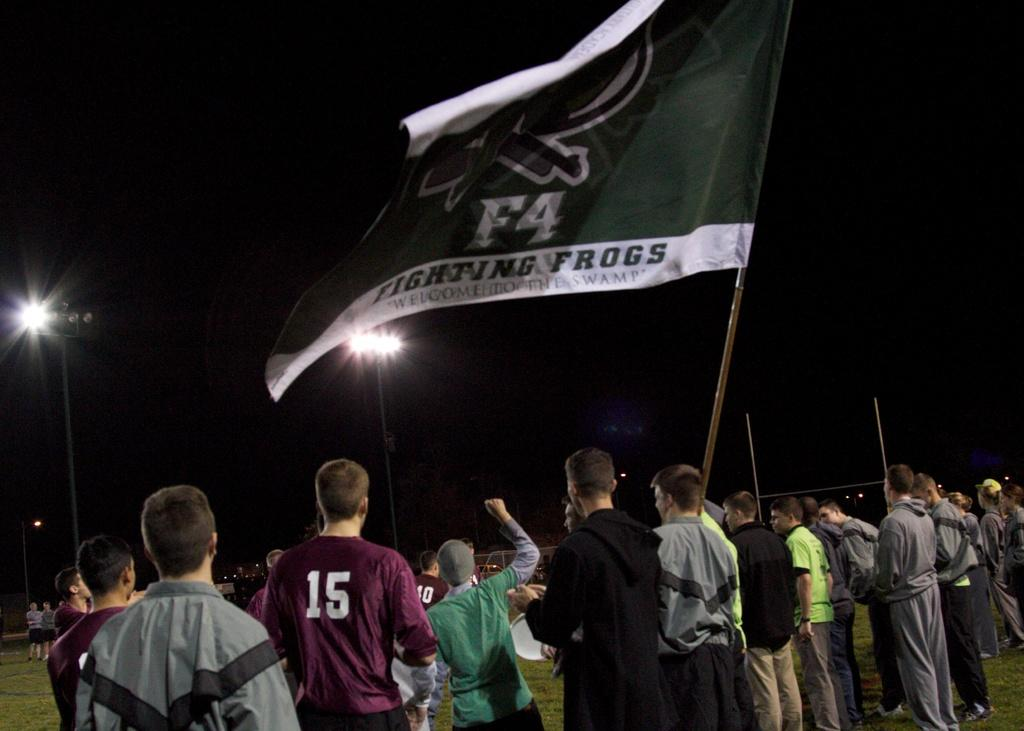What are the people in the image doing? The people in the image are standing on the ground. What type of vegetation can be seen in the image? There is grass visible in the image. What structures are present in the image? There are flagpoles in the image. What type of illumination is present in the image? There are lights in the image. What else can be seen in the image besides the people, grass, flagpoles, and lights? There are other objects in the image. How would you describe the overall lighting conditions in the image? The background of the image is dark. What type of hairstyle do the people in the image have? There is no information about the people's hairstyles in the image. What type of land can be seen in the image? The image does not show any specific type of land; it only shows people standing on the ground. Can you describe the romantic interaction between the people in the image? There is no romantic interaction depicted in the image; the people are simply standing on the ground. 